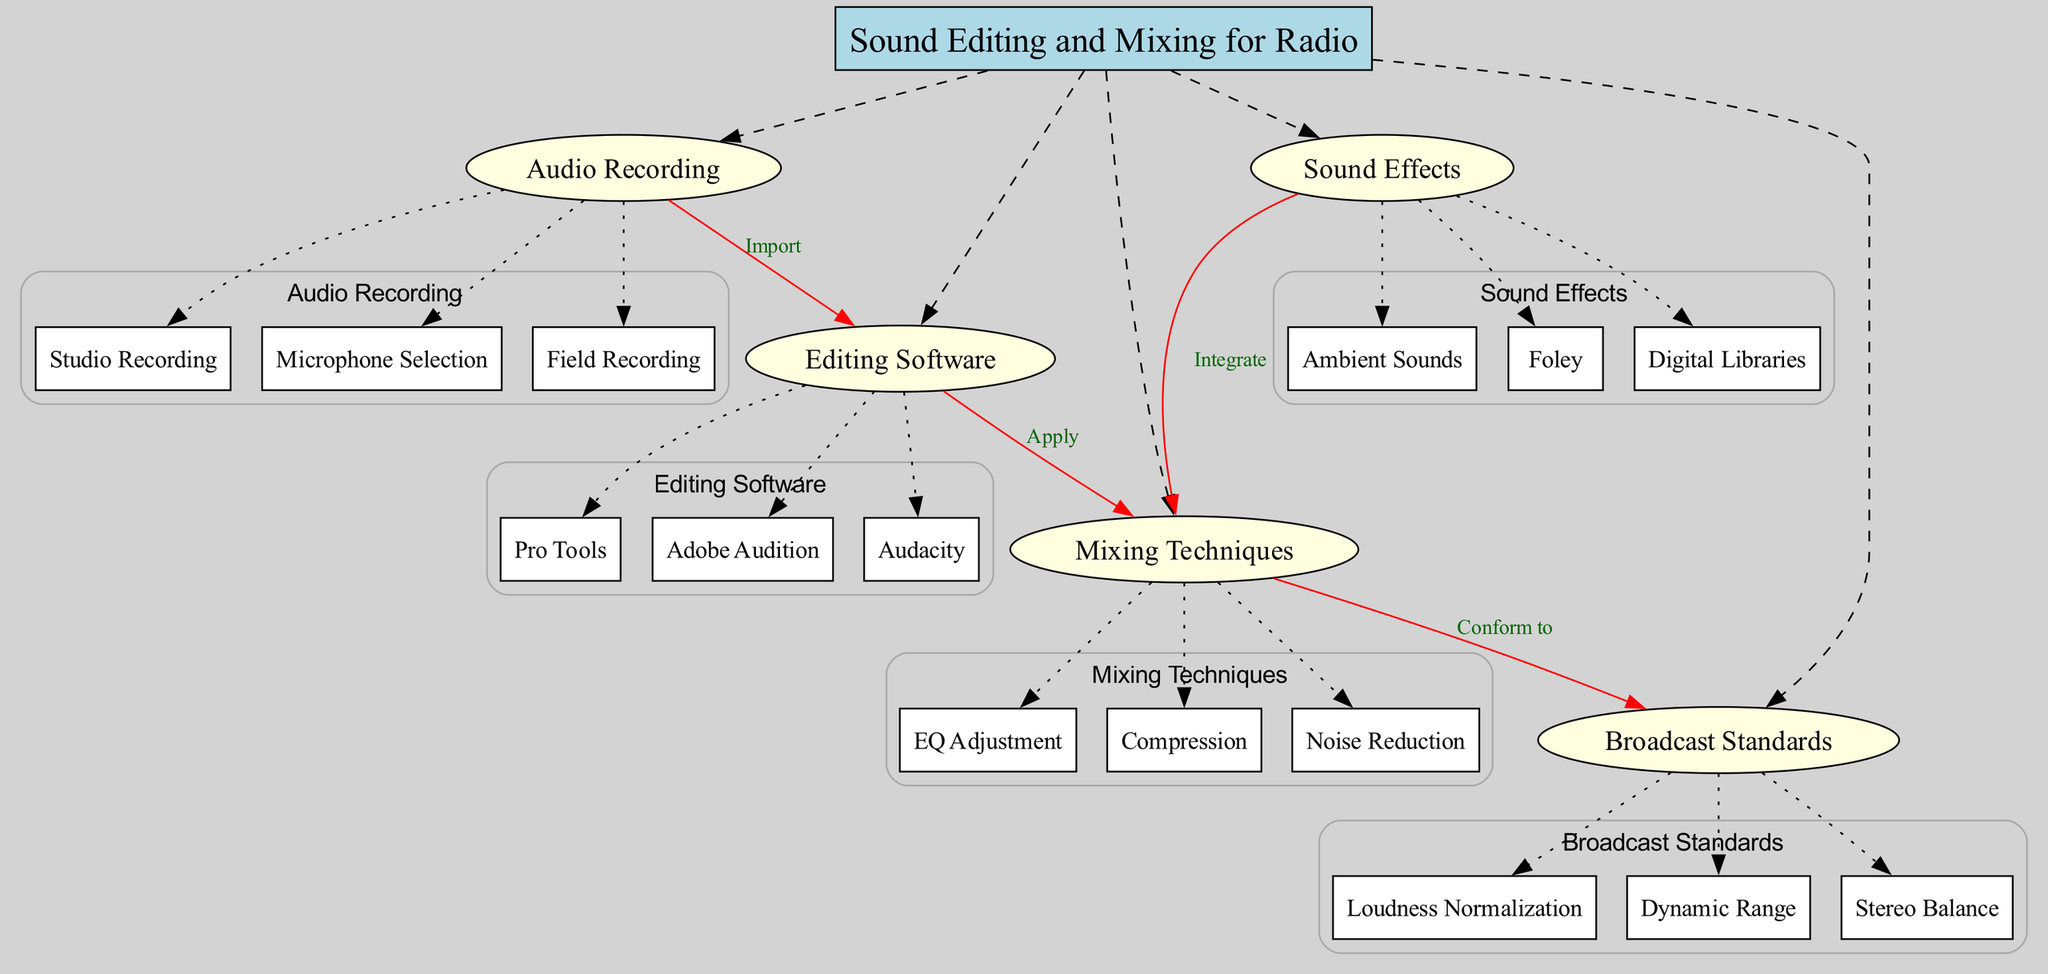What is the central concept of the diagram? The central concept is clearly labeled at the top of the diagram as "Sound Editing and Mixing for Radio." This is the main focus of the concept map and serves as the starting point for all other related nodes.
Answer: Sound Editing and Mixing for Radio How many main nodes are present in the diagram? The main nodes are listed directly under the central concept. There are five main nodes: Audio Recording, Editing Software, Mixing Techniques, Sound Effects, and Broadcast Standards. Counting these gives a total of five.
Answer: 5 What does the node "Audio Recording" connect to? The node "Audio Recording" has a connection to "Editing Software" labeled as "Import." This indicates that audio recordings are imported into the editing software for further processing.
Answer: Editing Software Which mixing techniques are highlighted in the diagram? The mixing techniques are shown as a sub-node under "Mixing Techniques." They include EQ Adjustment, Compression, and Noise Reduction. Each of these techniques plays a critical role in the mixing process.
Answer: EQ Adjustment, Compression, Noise Reduction What is the relationship between "Sound Effects" and "Mixing Techniques"? The diagram shows an integration relationship between these two nodes, indicated by an edge labeled "Integrate." This means that sound effects are combined with mixing techniques during the production process.
Answer: Integrate What are the broadcast standards addressed in the diagram? The broadcast standards are listed as sub-nodes under "Broadcast Standards" and include Loudness Normalization, Dynamic Range, and Stereo Balance. These standards ensure that the final broadcasted audio meets industry requirements.
Answer: Loudness Normalization, Dynamic Range, Stereo Balance Which editing software is specifically mentioned in the diagram? Under the "Editing Software" main node, the diagram lists three specific software options: Pro Tools, Adobe Audition, and Audacity. These are well-known applications used for audio editing.
Answer: Pro Tools, Adobe Audition, Audacity How does "Mixing Techniques" conform to "Broadcast Standards"? The diagram shows an edge labeled "Conform to" connecting "Mixing Techniques" to "Broadcast Standards." This indicates that the mixing techniques applied must adhere to established broadcast standards to ensure quality.
Answer: Conform to What sub-node connects to "Editing Software"? The only sub-node connected to "Editing Software" through the edge labeled "Apply" is "Mixing Techniques." This relationship indicates the process in which editing software is used to apply mixing techniques on the audio.
Answer: Mixing Techniques 